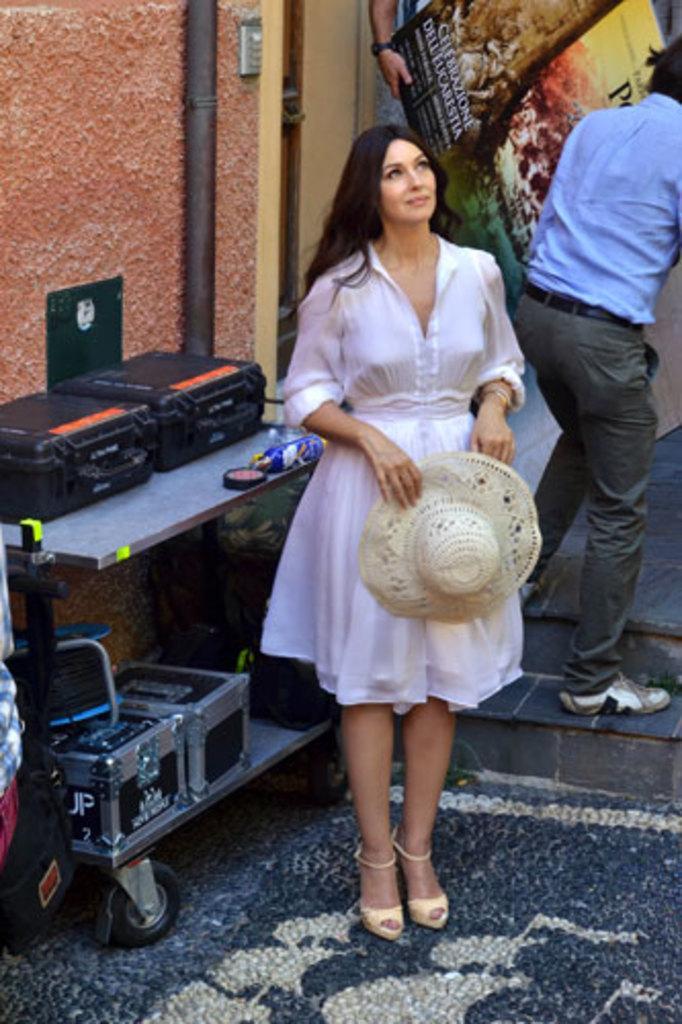Can you describe this image briefly? This picture seems to be clicked inside. In the center there is a woman wearing white color dress, holding a hat and standing on the ground. The ground is covered with the floor mat. On the left we can see a table on the top of which suitcases and some other items are placed. On the left corner there is a person wearing a sling bag. In the background there is a wall, metal rod and we can see the two persons holding some object and seems to be walking on the ground and we can see the text and some pictures on the object. 